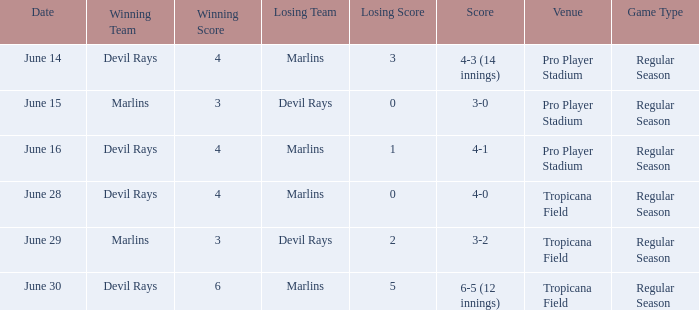Who won by a score of 4-1? Devil Rays. 